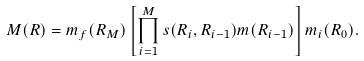Convert formula to latex. <formula><loc_0><loc_0><loc_500><loc_500>M ( { R } ) = m _ { f } ( R _ { M } ) \left [ \prod ^ { M } _ { i = 1 } s ( R _ { i } , R _ { i - 1 } ) m ( R _ { i - 1 } ) \right ] m _ { i } ( R _ { 0 } ) .</formula> 